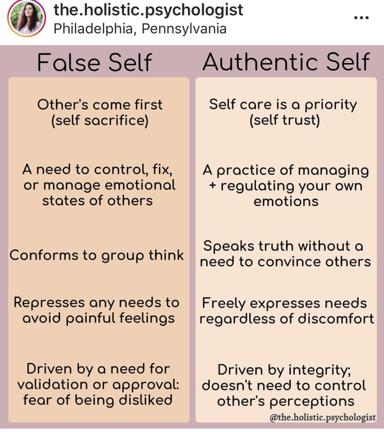How can transitioning from the false self to the authentic self impact a person's mental health? Transitioning from the false self to the authentic self can profoundly impact mental health positively. By moving away from behaviors driven by external approval and emotional suppression, an individual can experience reduced stress, anxiety, and depression. Embracing the authentic self encourages emotional regulation, self-respect, and integrity, which enhance psychological well-being and build stronger, more genuine relationships. This transformation allows individuals to live more fully and truly to their values and desires. 